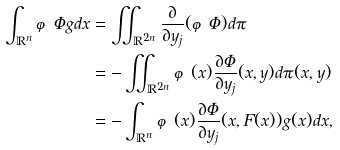Convert formula to latex. <formula><loc_0><loc_0><loc_500><loc_500>\int _ { \mathbb { R } ^ { n } } \varphi \Phi g d x & = \iint _ { \mathbb { R } ^ { 2 n } } \frac { \partial } { \partial y _ { j } } ( \varphi \Phi ) d \pi \\ & = - \iint _ { \mathbb { R } ^ { 2 n } } \varphi ( x ) \frac { \partial \Phi } { \partial y _ { j } } ( x , y ) d \pi ( x , y ) \\ & = - \int _ { \mathbb { R } ^ { n } } \varphi ( x ) \frac { \partial \Phi } { \partial y _ { j } } ( x , F ( x ) ) g ( x ) d x ,</formula> 